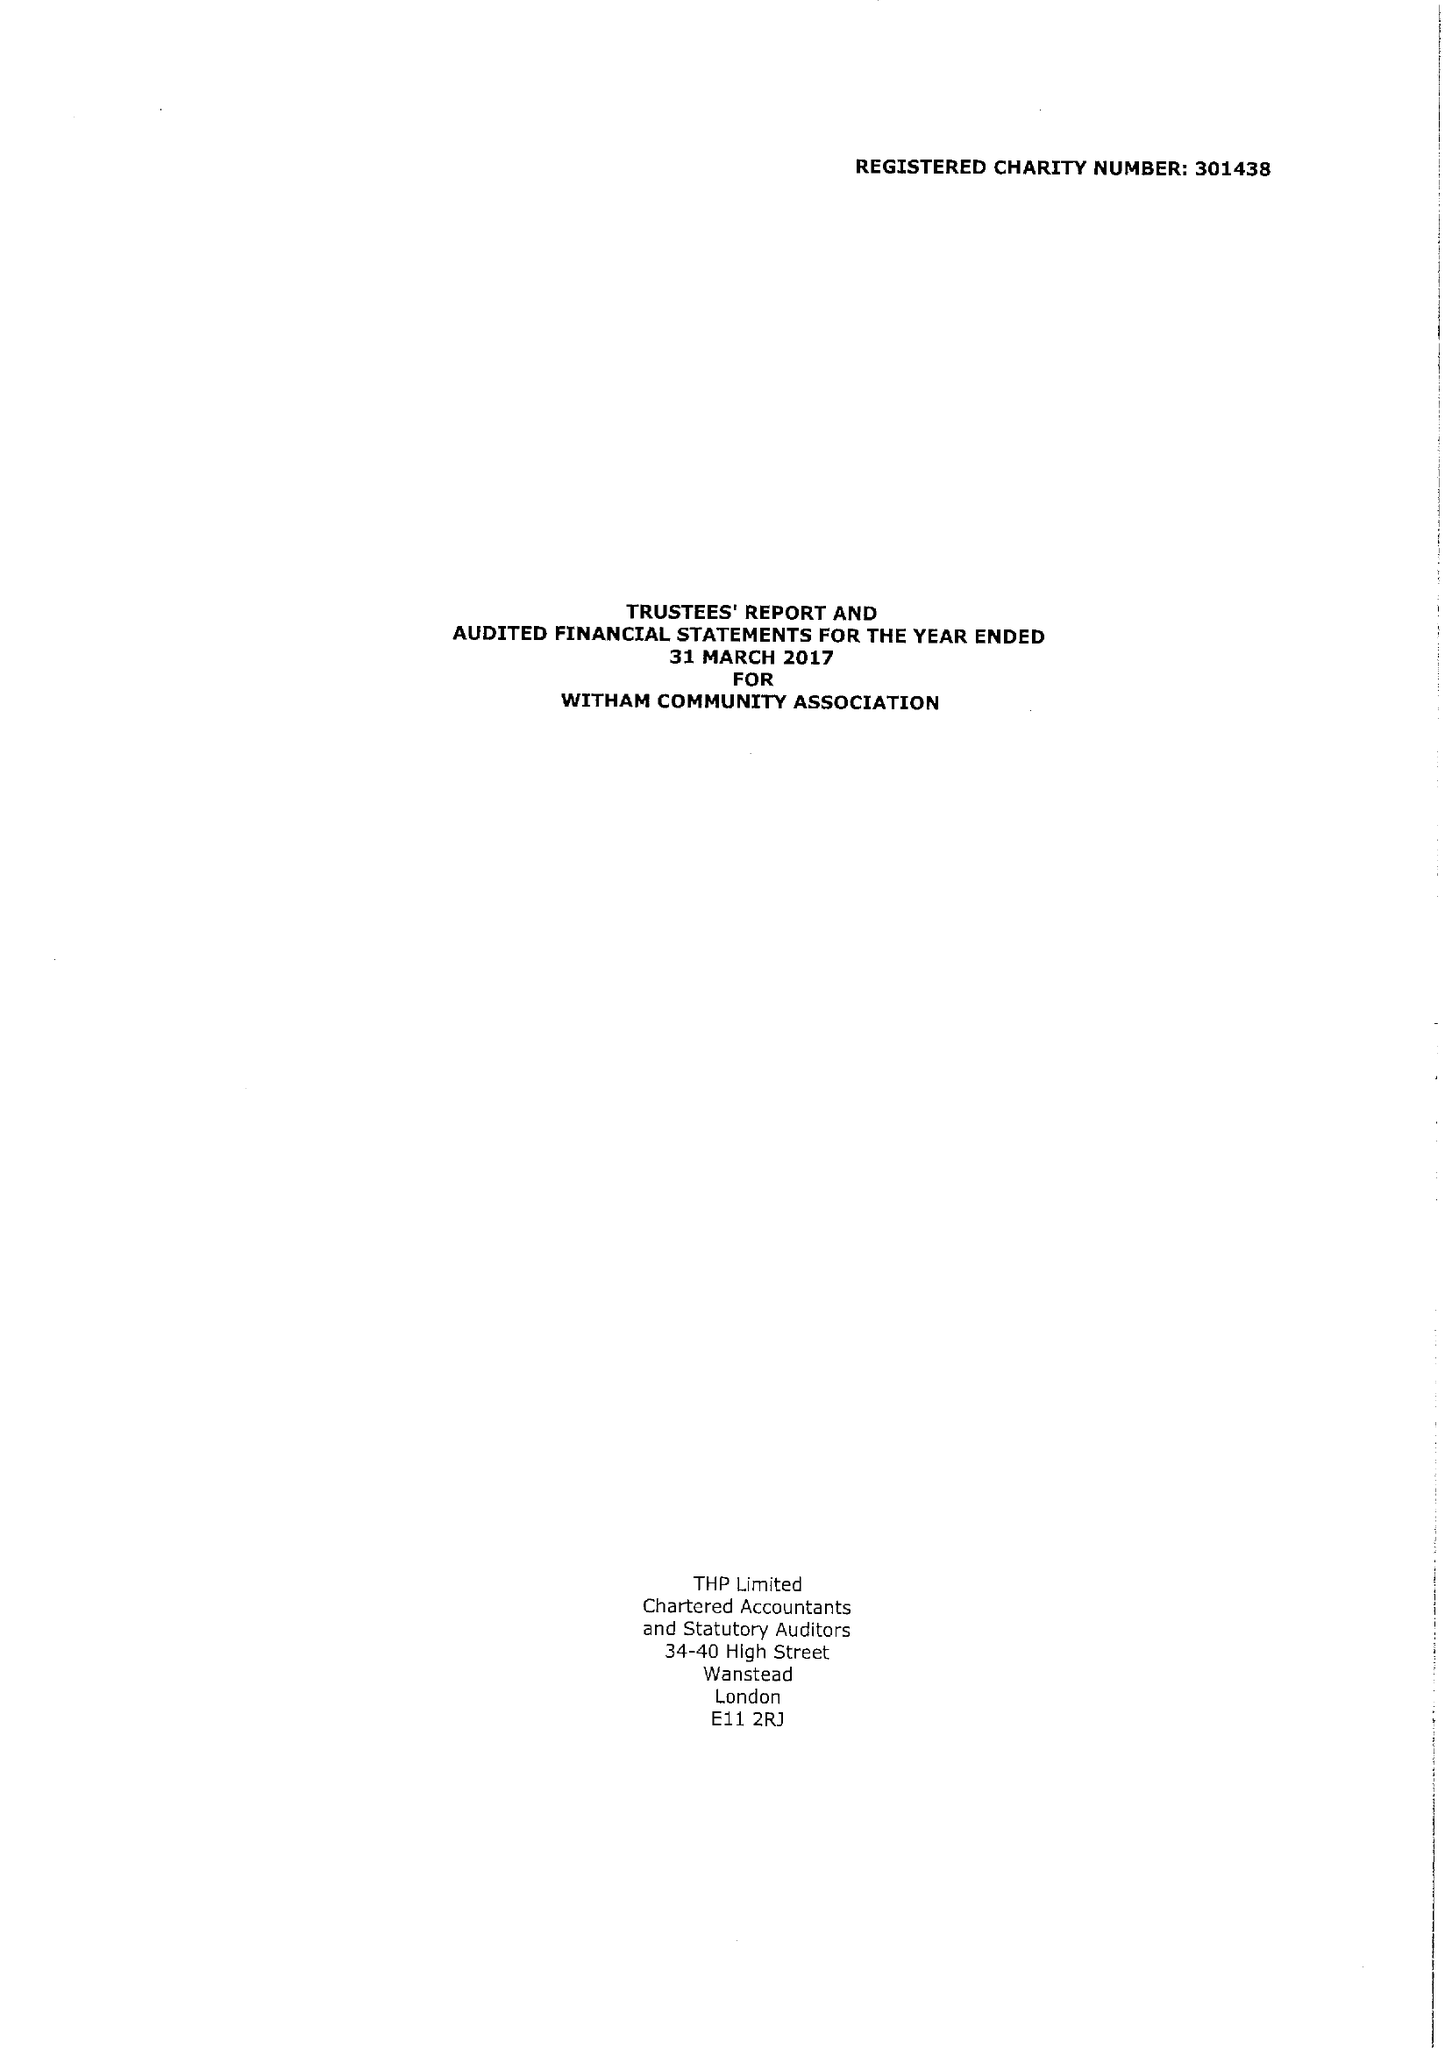What is the value for the charity_number?
Answer the question using a single word or phrase. 301438 